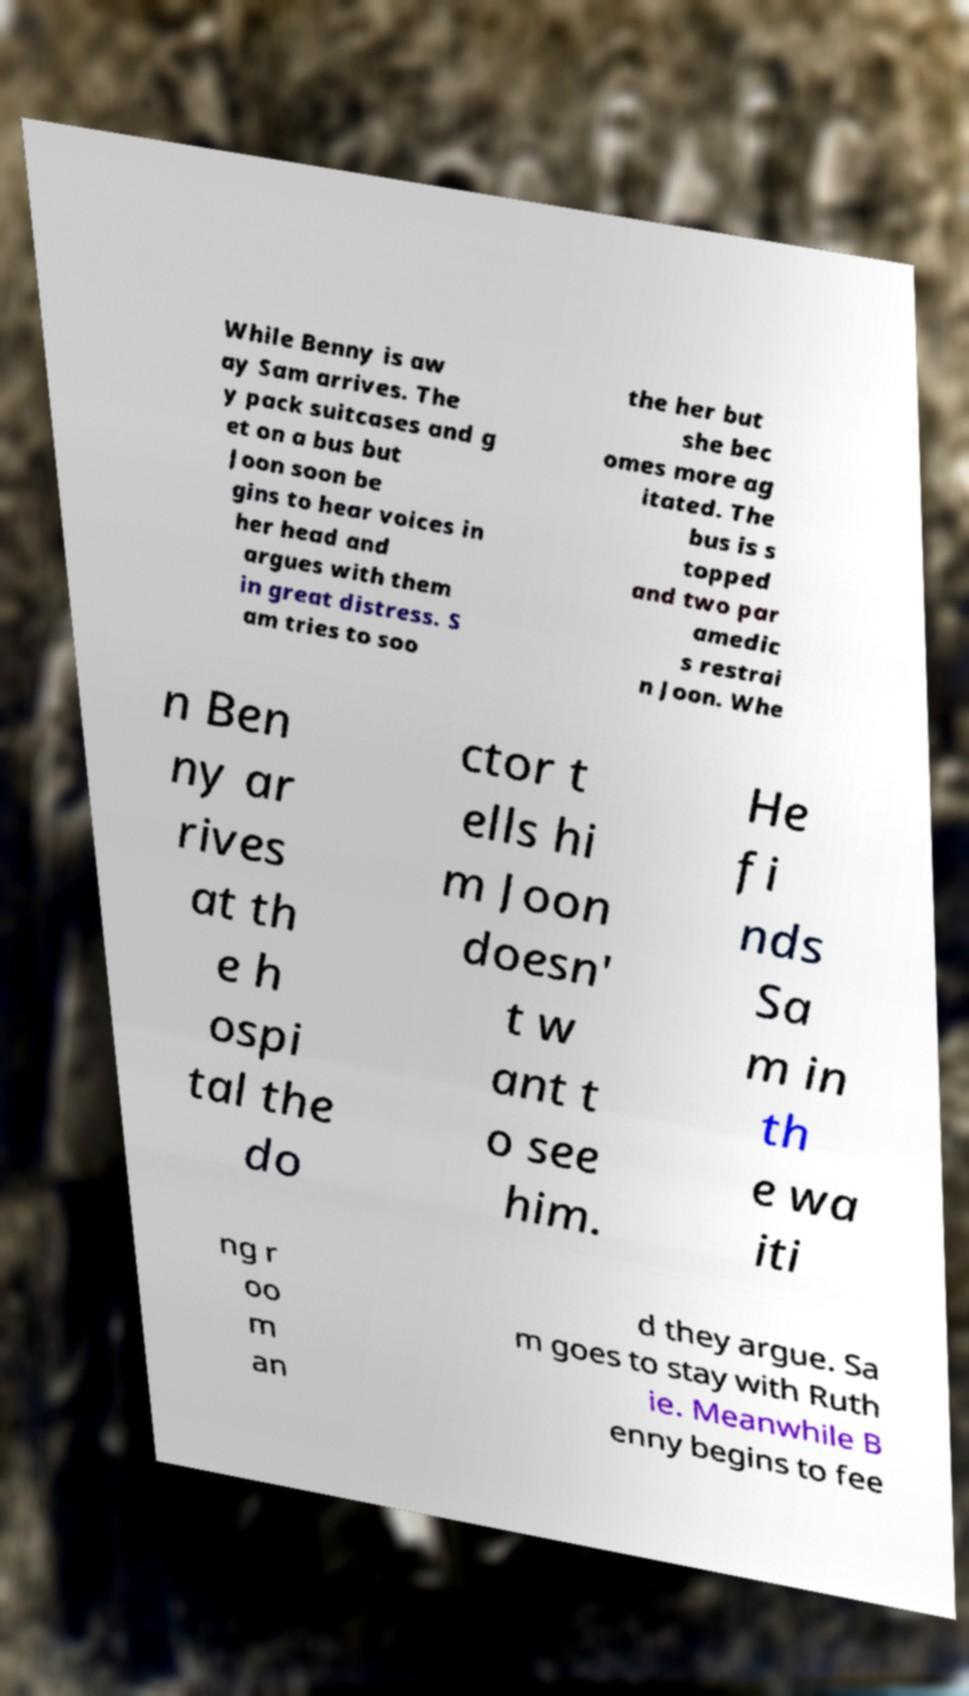Can you accurately transcribe the text from the provided image for me? While Benny is aw ay Sam arrives. The y pack suitcases and g et on a bus but Joon soon be gins to hear voices in her head and argues with them in great distress. S am tries to soo the her but she bec omes more ag itated. The bus is s topped and two par amedic s restrai n Joon. Whe n Ben ny ar rives at th e h ospi tal the do ctor t ells hi m Joon doesn' t w ant t o see him. He fi nds Sa m in th e wa iti ng r oo m an d they argue. Sa m goes to stay with Ruth ie. Meanwhile B enny begins to fee 